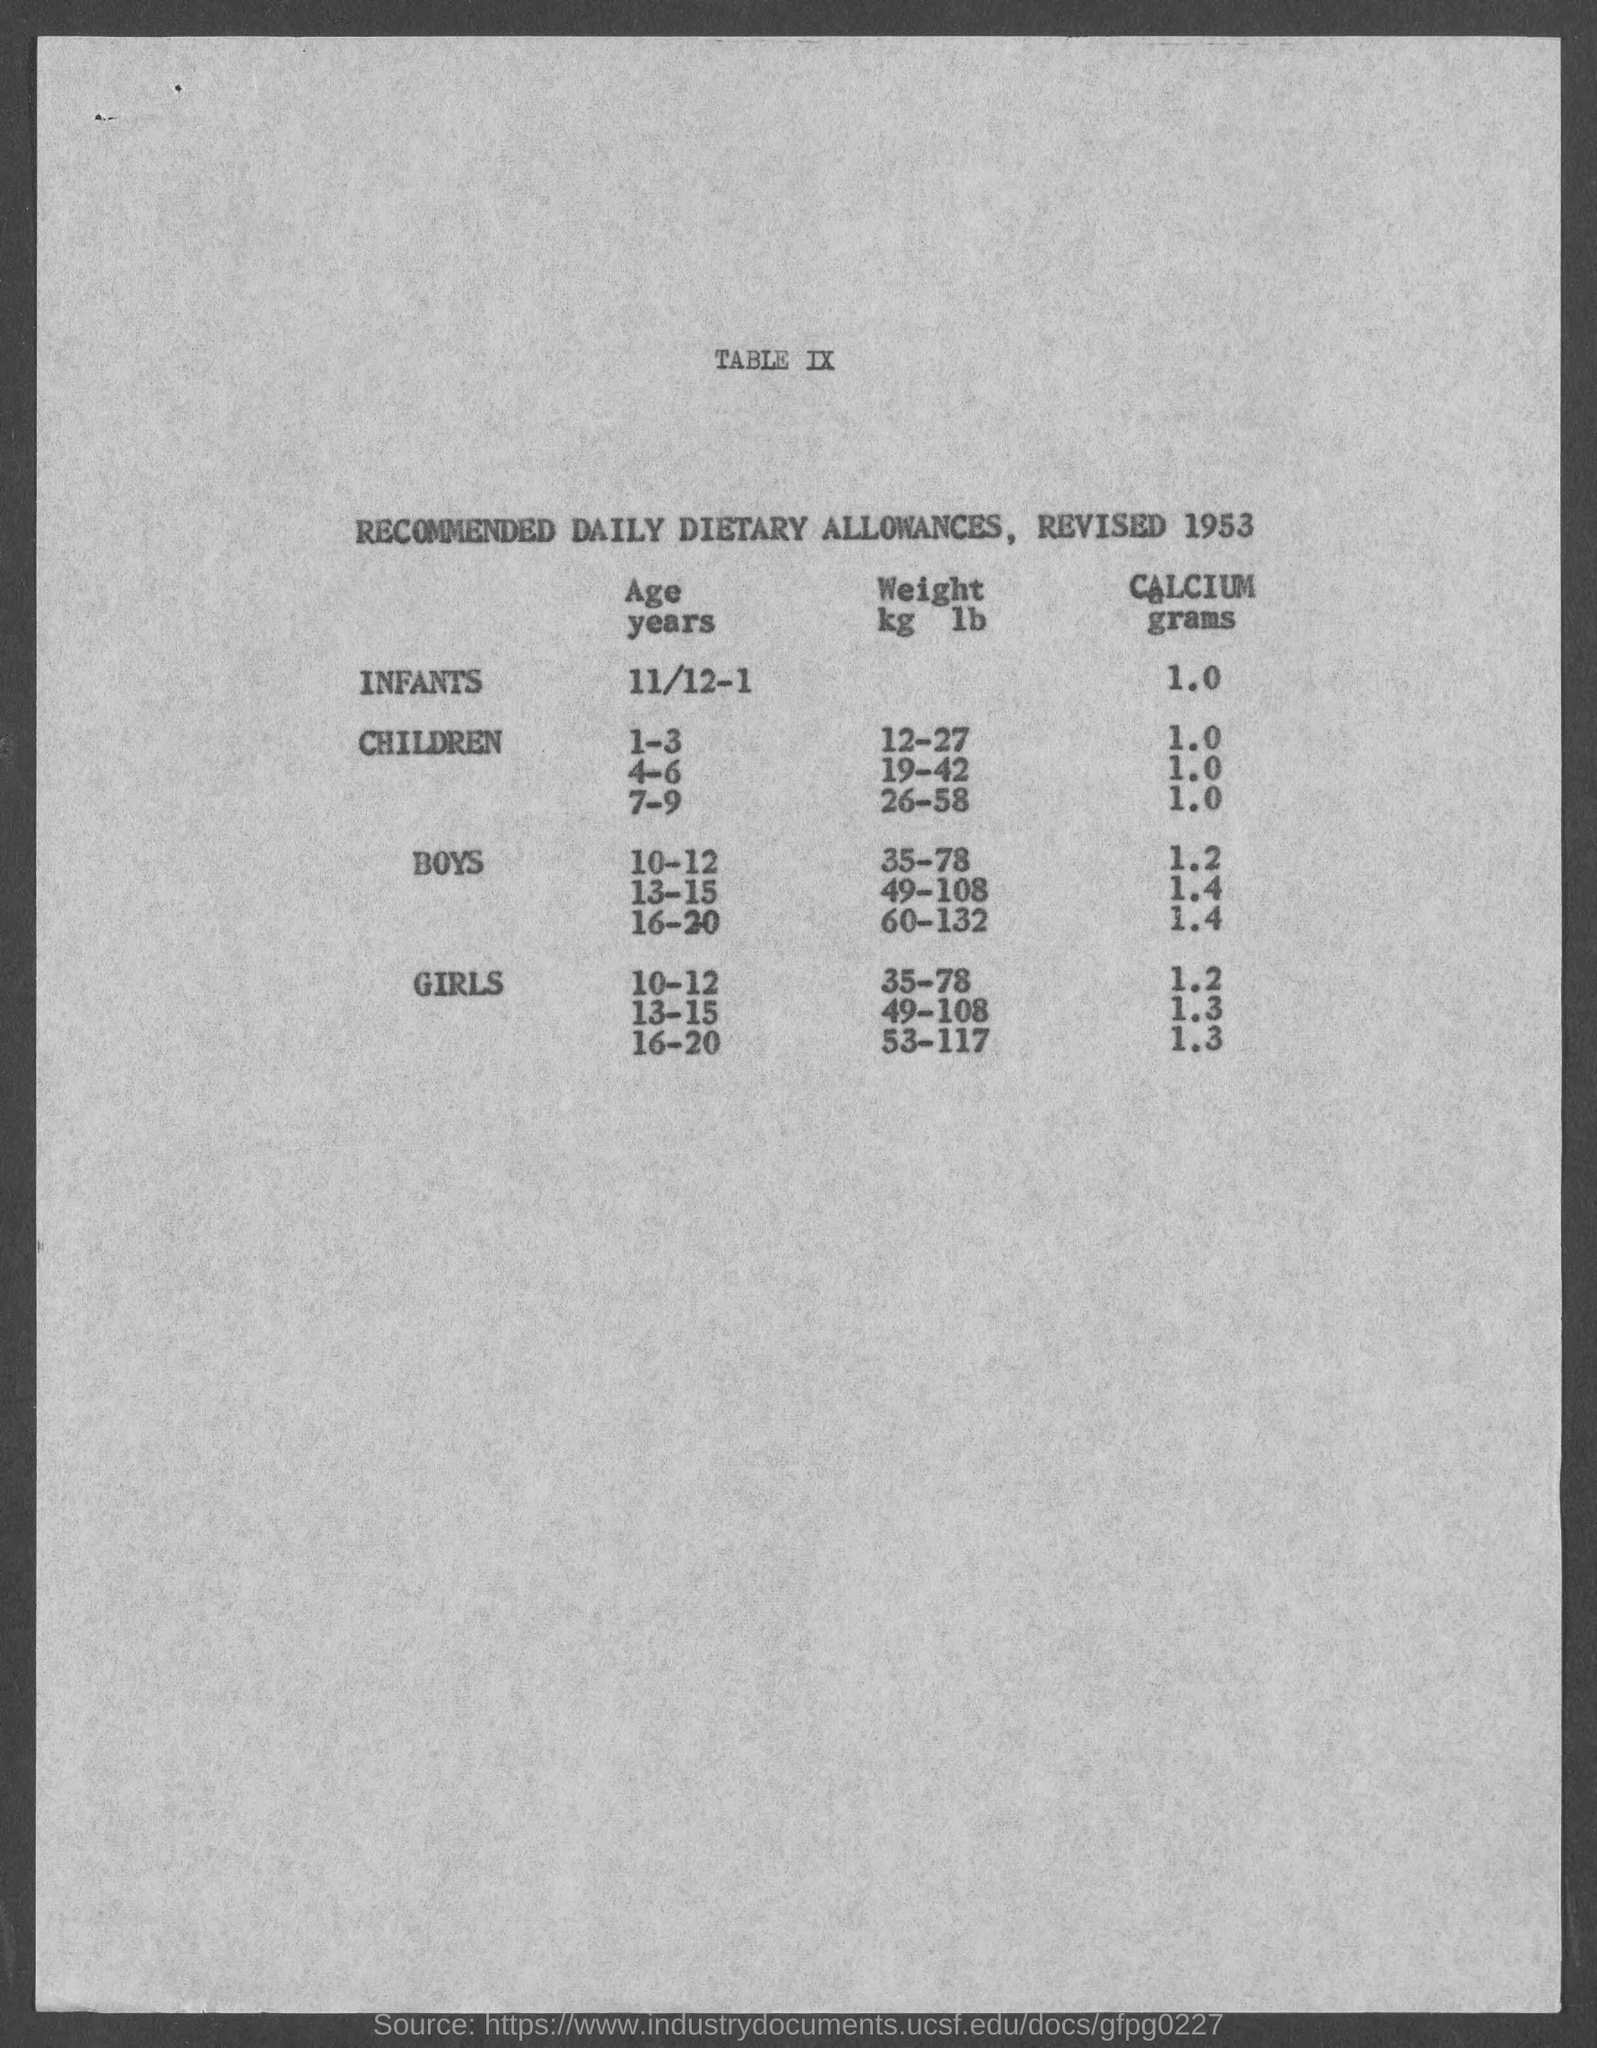What is the recommended weight(kg/lb) for boys in the age group 10-12? According to the document from 1953 depicted in the image, the recommended weight range for boys aged 10-12 years is 35-78 kilograms (77-172 pounds). It's important to note that these figures are based on standards from 1953 and may not reflect current health guidelines. For contemporary advice, it's recommended to consult updated health resources or a medical professional. 